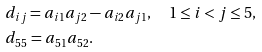Convert formula to latex. <formula><loc_0><loc_0><loc_500><loc_500>& d _ { i j } = a _ { i 1 } a _ { j 2 } - a _ { i 2 } a _ { j 1 } , \quad 1 \leq i < j \leq 5 , \\ & d _ { 5 5 } = a _ { 5 1 } a _ { 5 2 } .</formula> 